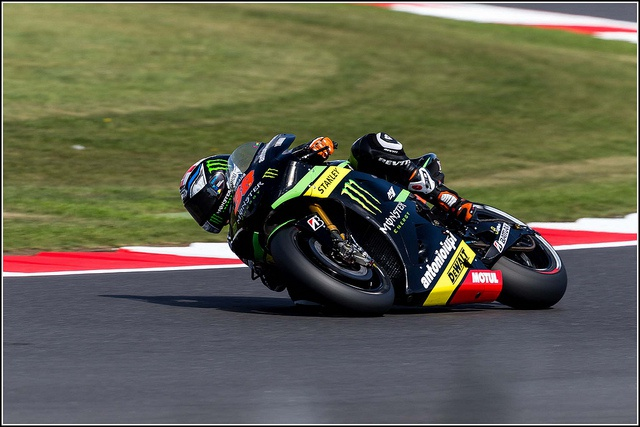Describe the objects in this image and their specific colors. I can see motorcycle in black, gray, navy, and white tones and people in black, lightgray, gray, and darkgray tones in this image. 